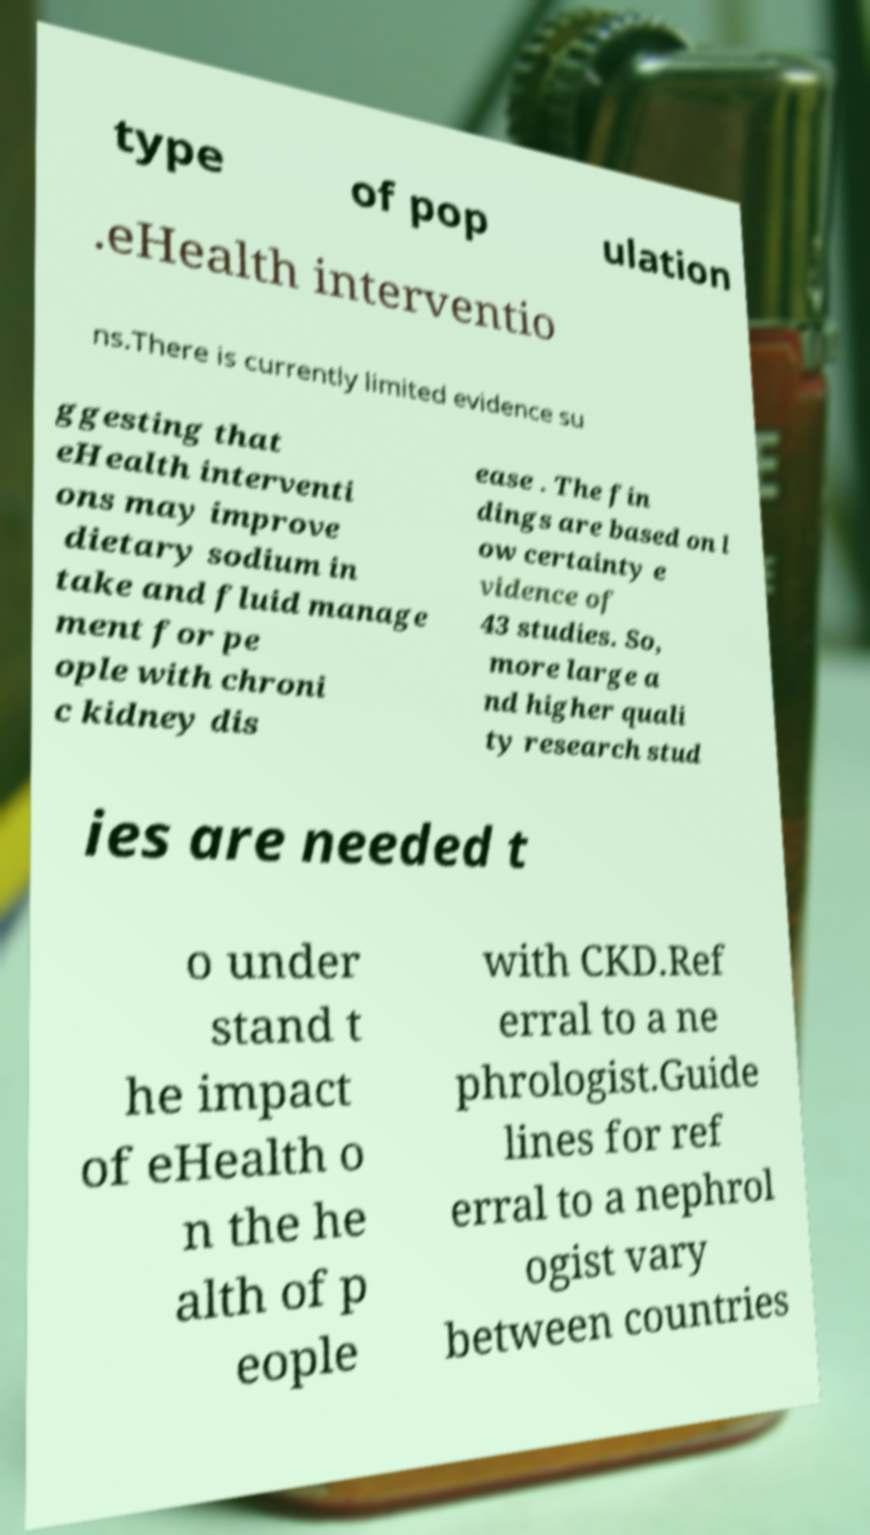For documentation purposes, I need the text within this image transcribed. Could you provide that? type of pop ulation .eHealth interventio ns.There is currently limited evidence su ggesting that eHealth interventi ons may improve dietary sodium in take and fluid manage ment for pe ople with chroni c kidney dis ease . The fin dings are based on l ow certainty e vidence of 43 studies. So, more large a nd higher quali ty research stud ies are needed t o under stand t he impact of eHealth o n the he alth of p eople with CKD.Ref erral to a ne phrologist.Guide lines for ref erral to a nephrol ogist vary between countries 